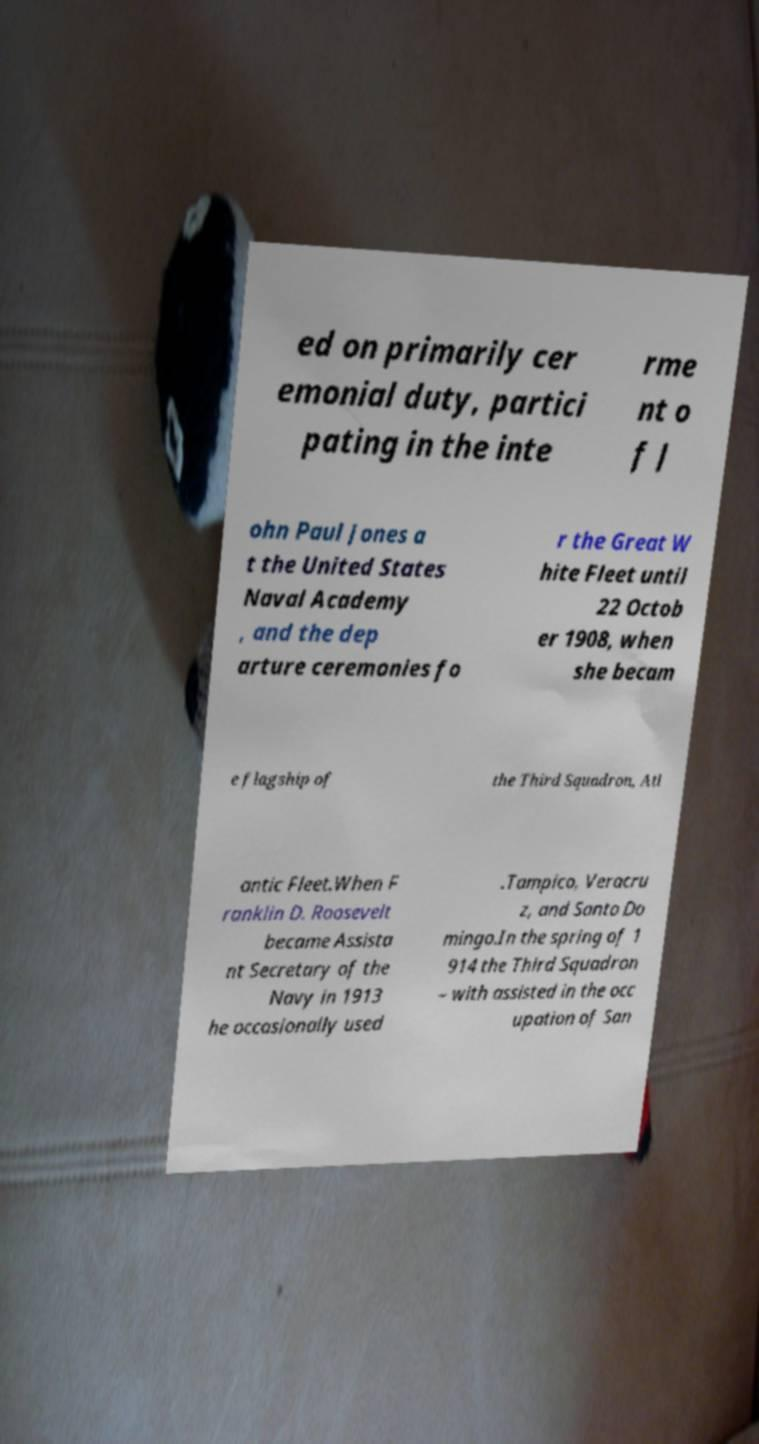Can you read and provide the text displayed in the image?This photo seems to have some interesting text. Can you extract and type it out for me? ed on primarily cer emonial duty, partici pating in the inte rme nt o f J ohn Paul Jones a t the United States Naval Academy , and the dep arture ceremonies fo r the Great W hite Fleet until 22 Octob er 1908, when she becam e flagship of the Third Squadron, Atl antic Fleet.When F ranklin D. Roosevelt became Assista nt Secretary of the Navy in 1913 he occasionally used .Tampico, Veracru z, and Santo Do mingo.In the spring of 1 914 the Third Squadron – with assisted in the occ upation of San 